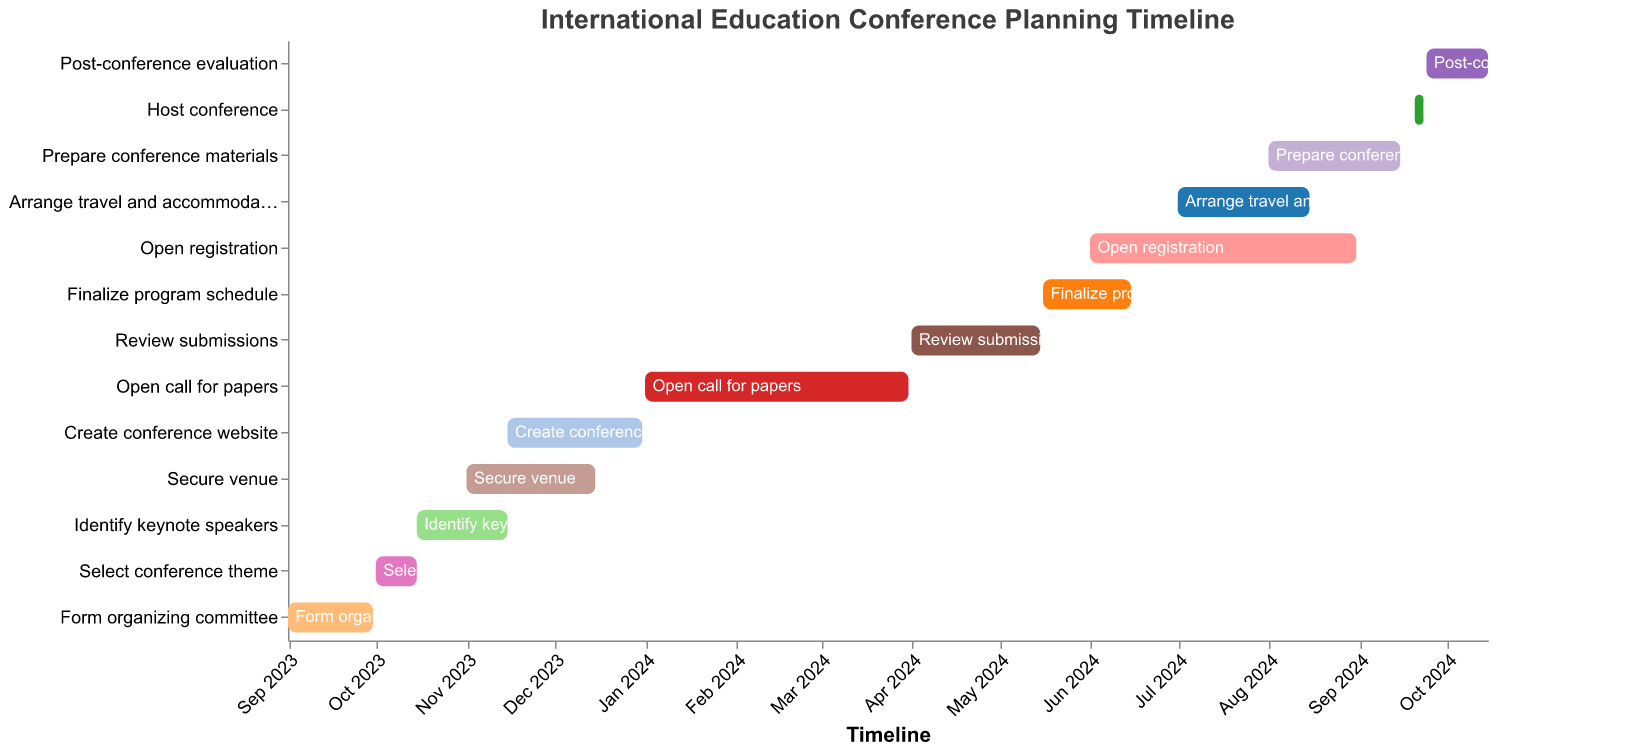How long does the task "Form organizing committee" take? The task "Form organizing committee" starts on September 1, 2023, and ends on September 30, 2023. Counting the days between these dates gives us 30 days.
Answer: 30 days Which task has the longest duration? By examining the Gantt Chart and comparing the start and end dates for each task, we can see that "Open call for papers" (January 1, 2024, to March 31, 2024) spans 90 days, which is the longest duration among all tasks.
Answer: Open call for papers What is the time gap between securing the venue and creating the conference website? "Secure venue" ends on December 15, 2023, and "Create conference website" starts on November 15, 2023. Since "Create conference website" overlaps with "Secure venue," there is no gap between these tasks.
Answer: No gap How many days are allocated for arranging travel and accommodations? The task "Arrange travel and accommodations" begins on July 1, 2024, and ends on August 15, 2024. Counting the days between these dates, we find 46 days allocated for this task.
Answer: 46 days Which tasks are active during November 2023? In November 2023, three tasks are active: "Identify keynote speakers" (October 15, 2023, to November 15, 2023), "Secure venue" (November 1, 2023, to December 15, 2023), and "Create conference website" (November 15, 2023, to December 31, 2023).
Answer: Identify keynote speakers, Secure venue, Create conference website What is the overlap period, if any, between "Review submissions" and "Finalize program schedule"? "Review submissions" ends on May 15, 2024, and "Finalize program schedule" starts on May 16, 2024. There is no overlap since one ends and the other begins the next day.
Answer: No overlap When does the task "Host conference" take place? The task "Host conference" occurs from September 20, 2024, to September 23, 2024, as indicated by its start and end dates.
Answer: September 20-23, 2024 During which months will the "Open registration" period last? The task "Open registration" lasts from June 1, 2024, to August 31, 2024, spanning the months of June, July, and August.
Answer: June, July, August What is the shortest task duration, and which task has this duration? The task "Select conference theme" has the shortest duration of 15 days, from October 1, 2023, to October 15, 2023.
Answer: Select conference theme, 15 days 